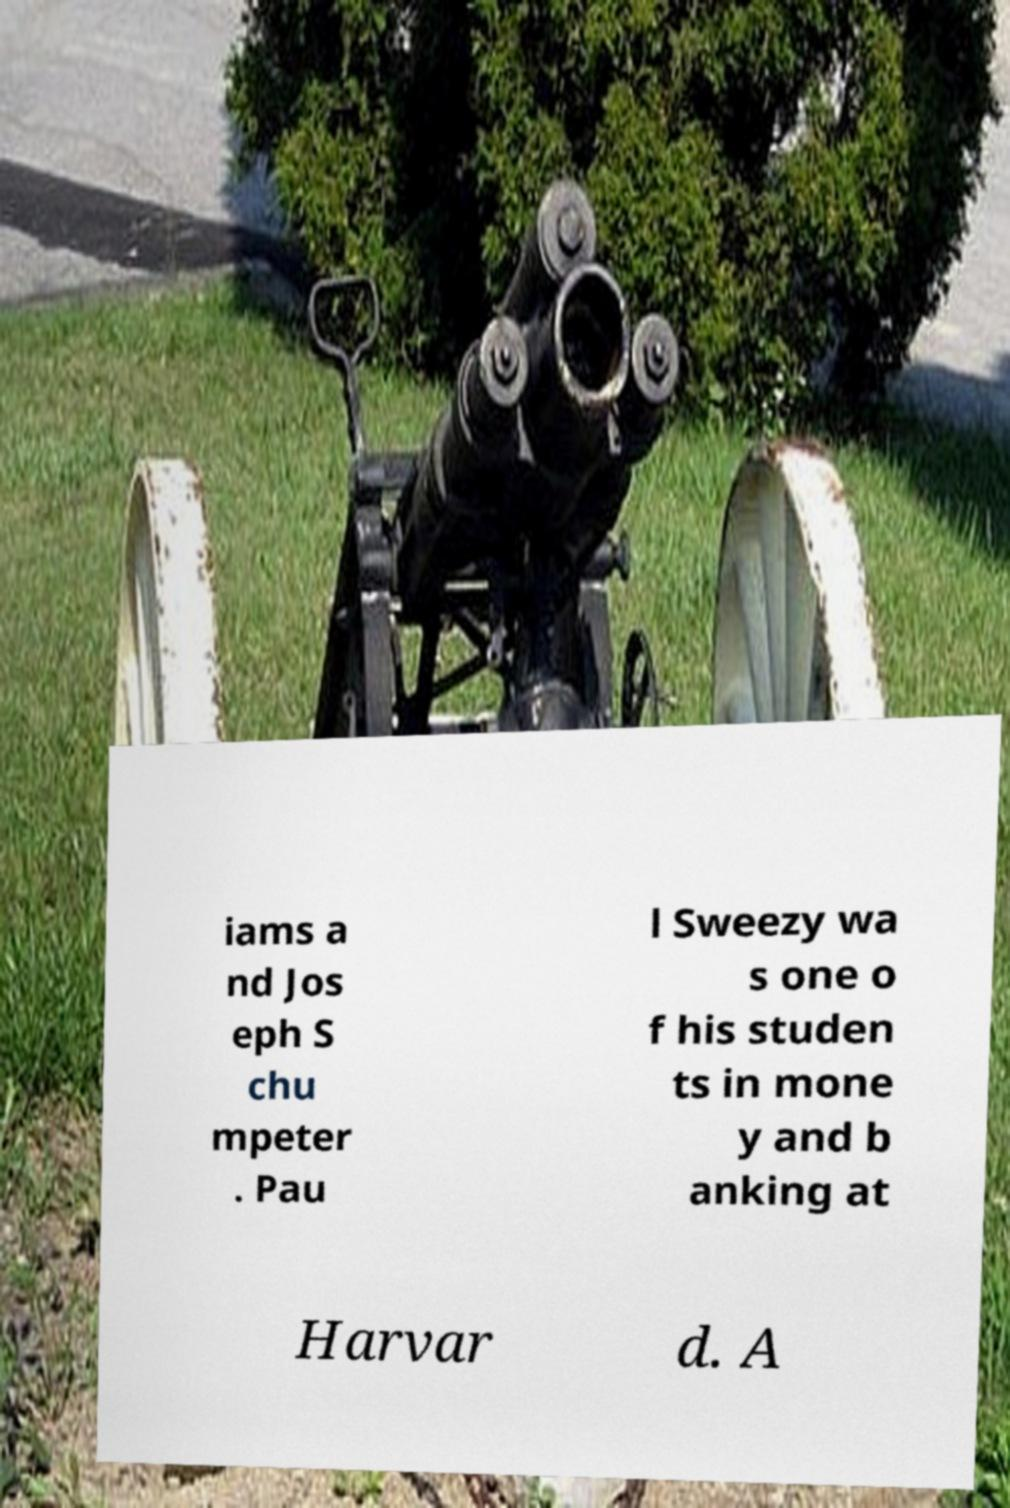Can you accurately transcribe the text from the provided image for me? iams a nd Jos eph S chu mpeter . Pau l Sweezy wa s one o f his studen ts in mone y and b anking at Harvar d. A 